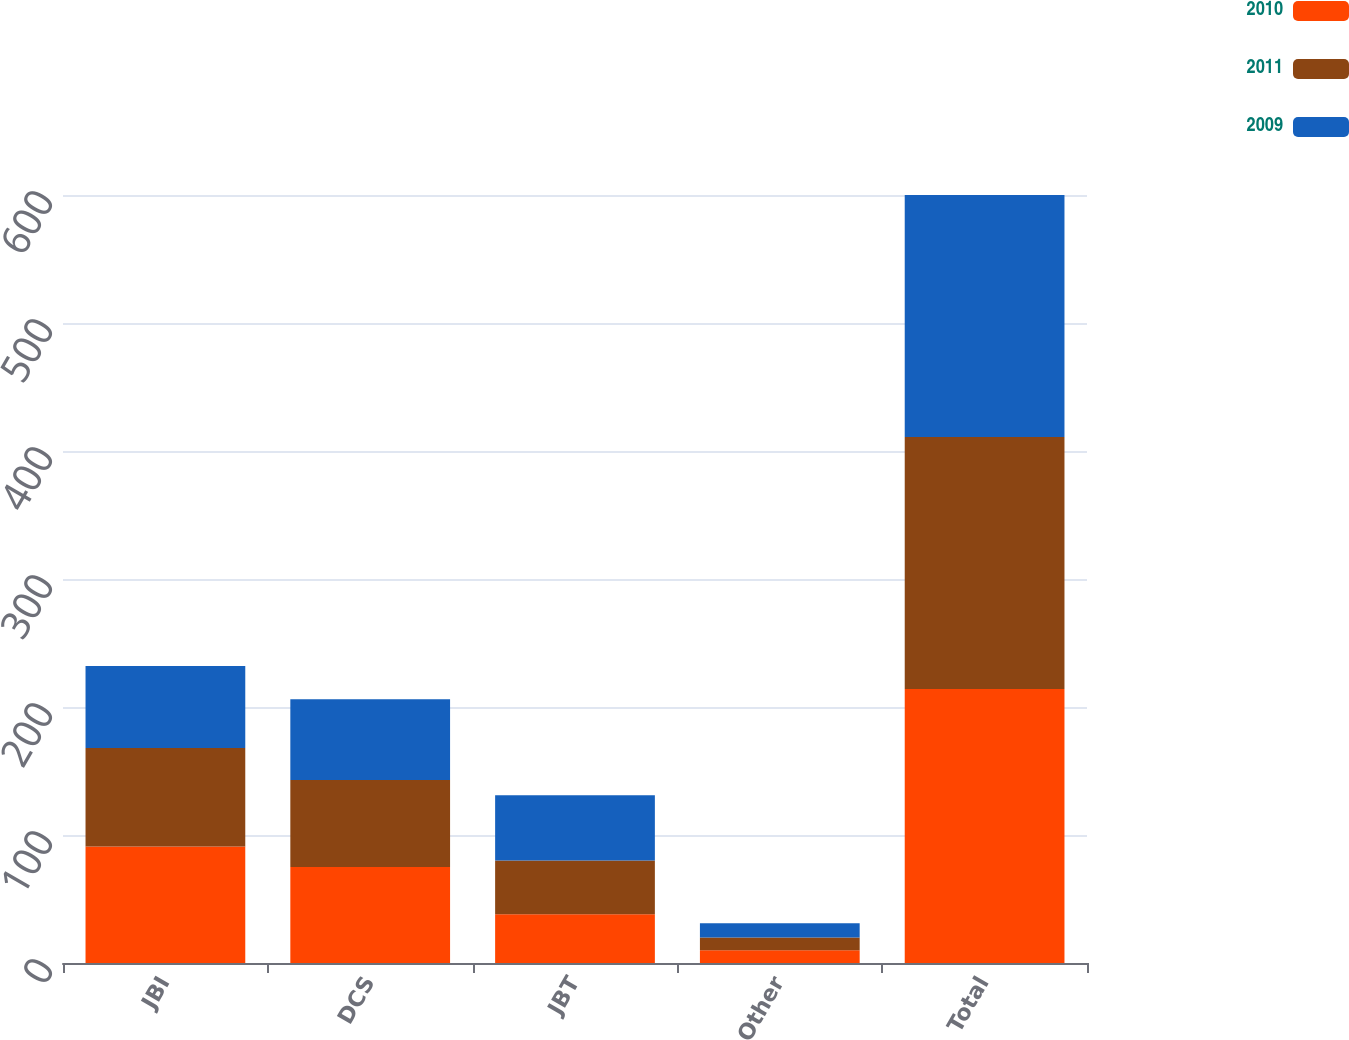Convert chart. <chart><loc_0><loc_0><loc_500><loc_500><stacked_bar_chart><ecel><fcel>JBI<fcel>DCS<fcel>JBT<fcel>Other<fcel>Total<nl><fcel>2010<fcel>91<fcel>75<fcel>38<fcel>10<fcel>214<nl><fcel>2011<fcel>77<fcel>68<fcel>42<fcel>10<fcel>197<nl><fcel>2009<fcel>64<fcel>63<fcel>51<fcel>11<fcel>189<nl></chart> 